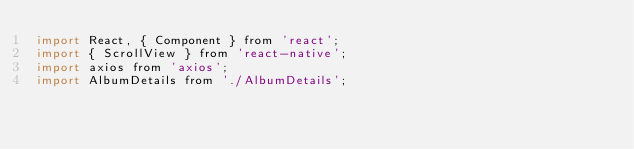<code> <loc_0><loc_0><loc_500><loc_500><_JavaScript_>import React, { Component } from 'react';
import { ScrollView } from 'react-native';
import axios from 'axios';
import AlbumDetails from './AlbumDetails';
</code> 